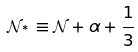Convert formula to latex. <formula><loc_0><loc_0><loc_500><loc_500>\mathcal { N } _ { ^ { * } } \equiv \mathcal { N } + \alpha + \frac { 1 } { 3 }</formula> 